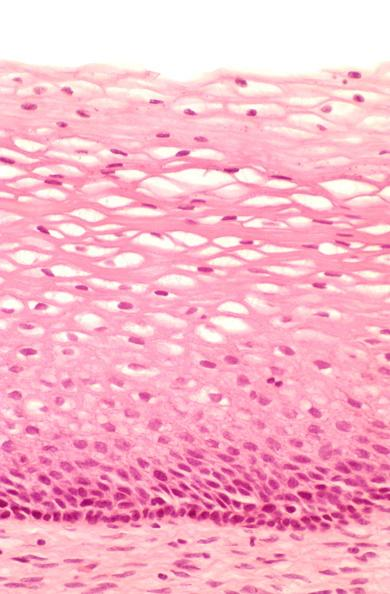does acid show cervix, mild dysplasia?
Answer the question using a single word or phrase. No 